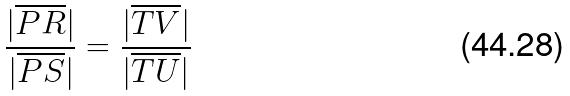Convert formula to latex. <formula><loc_0><loc_0><loc_500><loc_500>\frac { | \overline { P R } | } { | \overline { P S } | } = \frac { | \overline { T V } | } { | \overline { T U } | }</formula> 